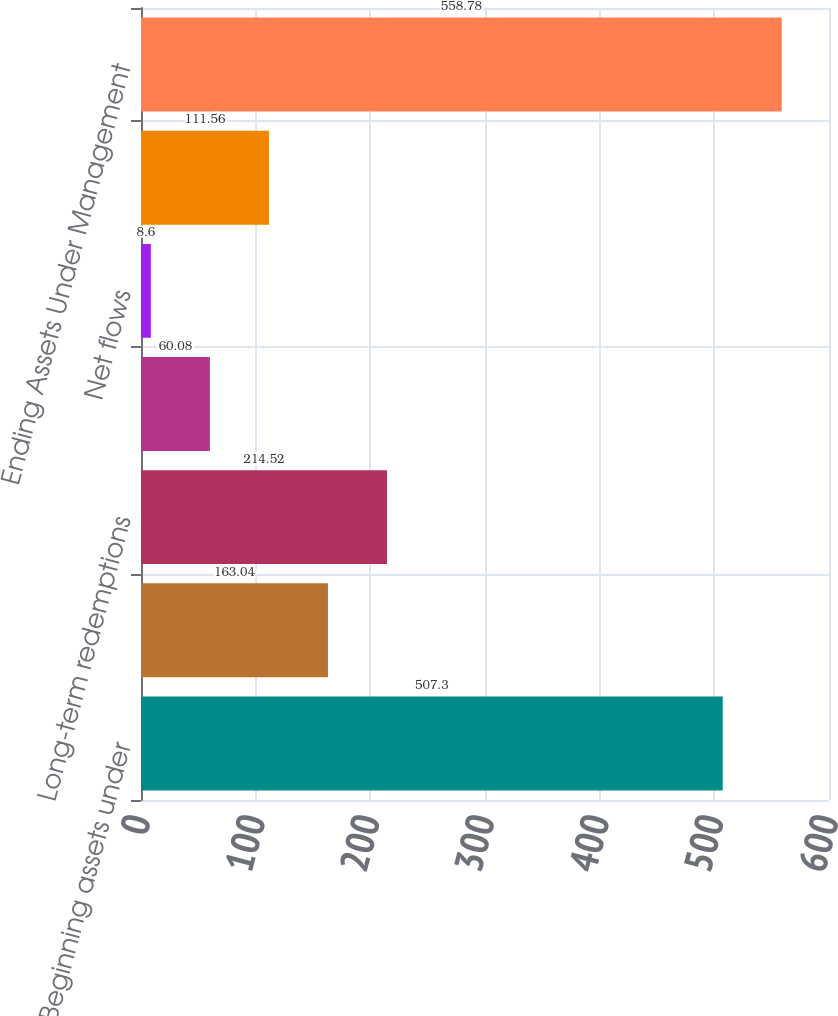Convert chart. <chart><loc_0><loc_0><loc_500><loc_500><bar_chart><fcel>Beginning assets under<fcel>Long-term sales<fcel>Long-term redemptions<fcel>Reinvested distributions<fcel>Net flows<fcel>Distributions<fcel>Ending Assets Under Management<nl><fcel>507.3<fcel>163.04<fcel>214.52<fcel>60.08<fcel>8.6<fcel>111.56<fcel>558.78<nl></chart> 